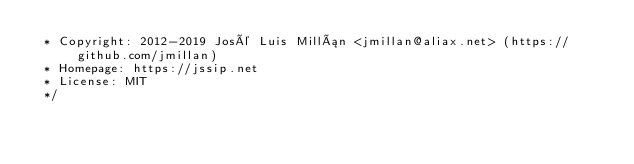<code> <loc_0><loc_0><loc_500><loc_500><_JavaScript_> * Copyright: 2012-2019 José Luis Millán <jmillan@aliax.net> (https://github.com/jmillan)
 * Homepage: https://jssip.net
 * License: MIT
 */
</code> 